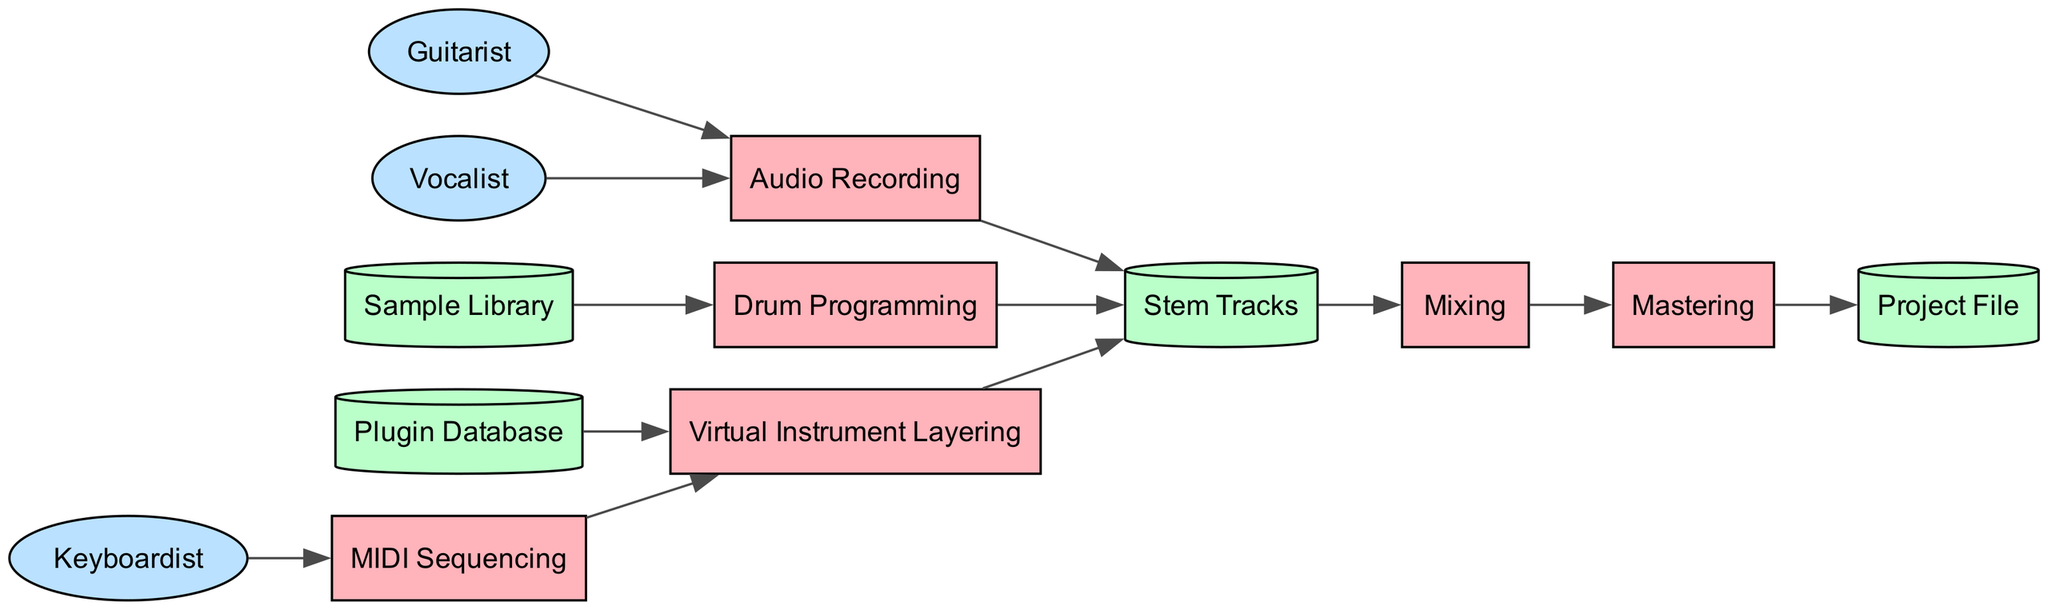What are the processes involved in the workflow? The diagram lists six processes: MIDI Sequencing, Virtual Instrument Layering, Audio Recording, Drum Programming, Mixing, and Mastering.
Answer: MIDI Sequencing, Virtual Instrument Layering, Audio Recording, Drum Programming, Mixing, Mastering How many data stores are present in the diagram? The diagram includes four data stores: Sample Library, Plugin Database, Project File, and Stem Tracks. Counting these gives a total of four.
Answer: 4 Which external entity contributes to Audio Recording? The diagram shows two external entities linked to Audio Recording: Guitarist and Vocalist. Therefore, the answer might include either of these entities.
Answer: Guitarist, Vocalist What is the final output of the workflow? The last process in the workflow is Mastering, which outputs to the Project File. Thus, the final output is the Project File.
Answer: Project File How many processes output to Stem Tracks? Three processes output to Stem Tracks: Audio Recording, Virtual Instrument Layering, and Drum Programming. Adding these up yields a total of three.
Answer: 3 Which process is connected to the Sample Library? The diagram indicates that Drum Programming is the process that utilizes the Sample Library.
Answer: Drum Programming What type of analysis combines both stem tracks and mixing? The workflow shows that Stem Tracks are directed to the Mixing process, which involves analyzing all the layered elements before finalizing the track. Thus, the answer highlights the interaction between these stages.
Answer: Mixing How many edges connect to the Mixing process? The Mixing process is connected by two edges: one from Stem Tracks and another going to Mastering. Counting these gives a total of two connections.
Answer: 2 Which external entity handles MIDI Sequencing? The diagram shows that Keyboardist is the external entity that contributes to the MIDI Sequencing process.
Answer: Keyboardist 